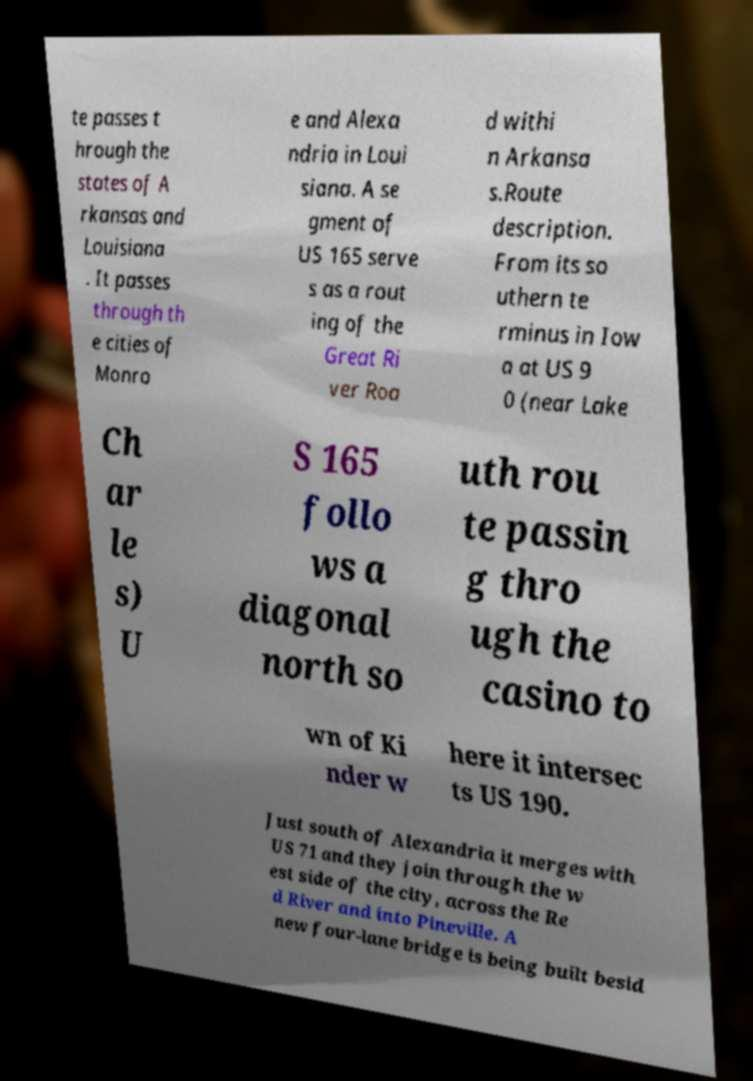Could you extract and type out the text from this image? te passes t hrough the states of A rkansas and Louisiana . It passes through th e cities of Monro e and Alexa ndria in Loui siana. A se gment of US 165 serve s as a rout ing of the Great Ri ver Roa d withi n Arkansa s.Route description. From its so uthern te rminus in Iow a at US 9 0 (near Lake Ch ar le s) U S 165 follo ws a diagonal north so uth rou te passin g thro ugh the casino to wn of Ki nder w here it intersec ts US 190. Just south of Alexandria it merges with US 71 and they join through the w est side of the city, across the Re d River and into Pineville. A new four-lane bridge is being built besid 